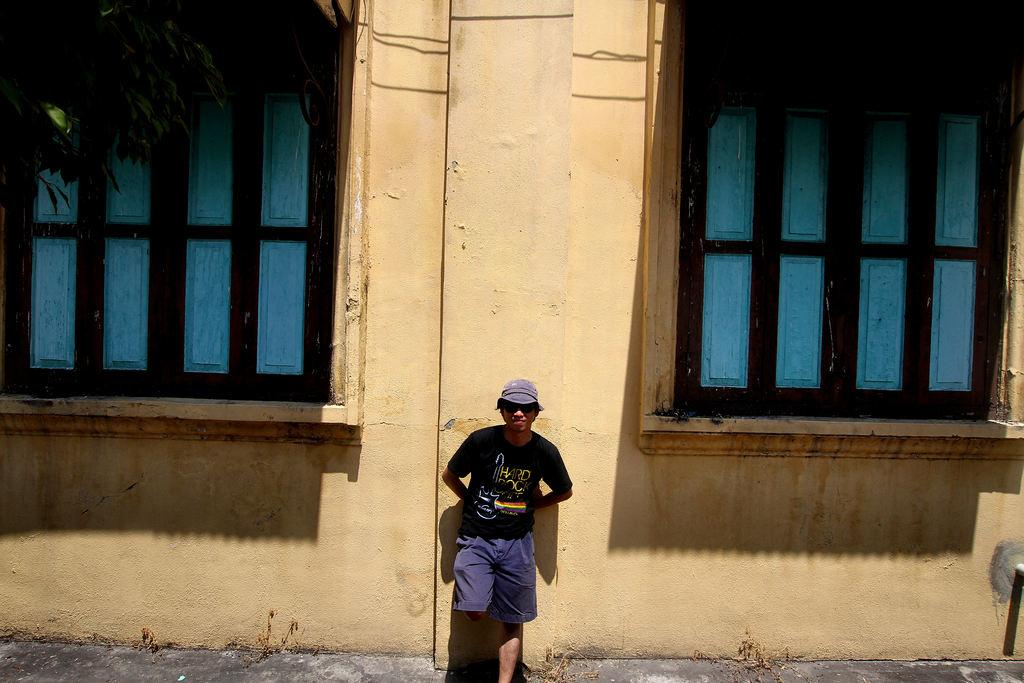Who or what is present in the image? There is a person in the image. What is the person wearing on their head? The person is wearing a cap. What is the person's posture in the image? The person is standing. What architectural features can be seen in the image? There are windows and a wall in the image. How many horses are visible in the image? There are no horses present in the image. What type of boats can be seen sailing in the background of the image? There are no boats visible in the image. 